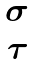<formula> <loc_0><loc_0><loc_500><loc_500>\begin{matrix} \sigma \\ \tau \end{matrix}</formula> 